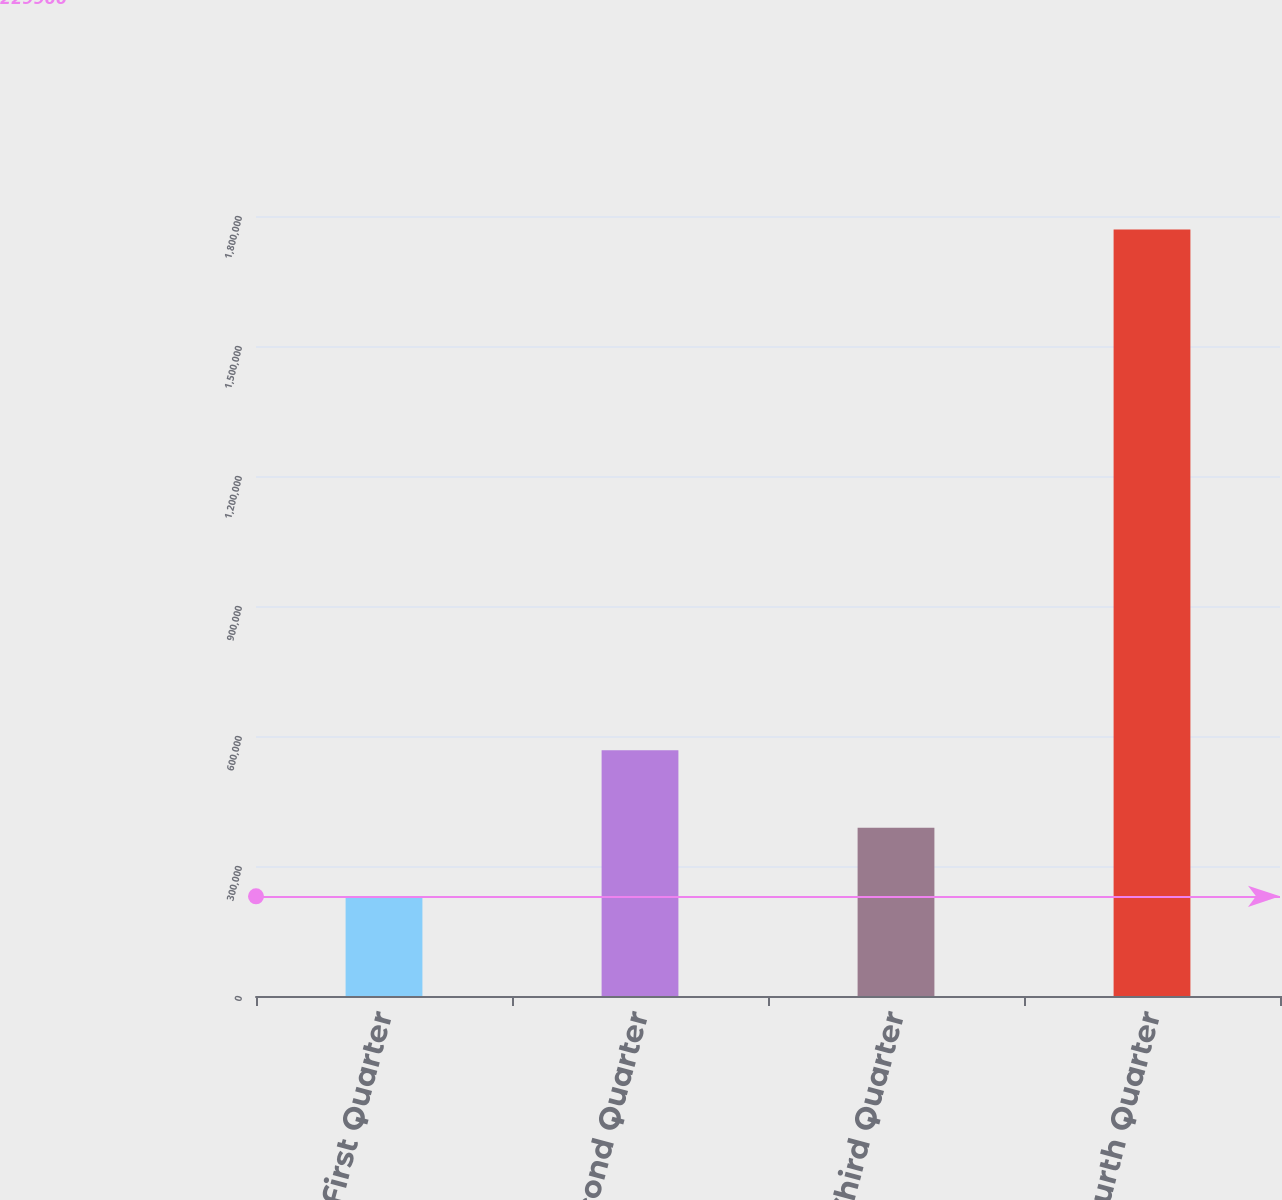Convert chart. <chart><loc_0><loc_0><loc_500><loc_500><bar_chart><fcel>First Quarter<fcel>Second Quarter<fcel>Third Quarter<fcel>Fourth Quarter<nl><fcel>229966<fcel>567314<fcel>388170<fcel>1.76907e+06<nl></chart> 